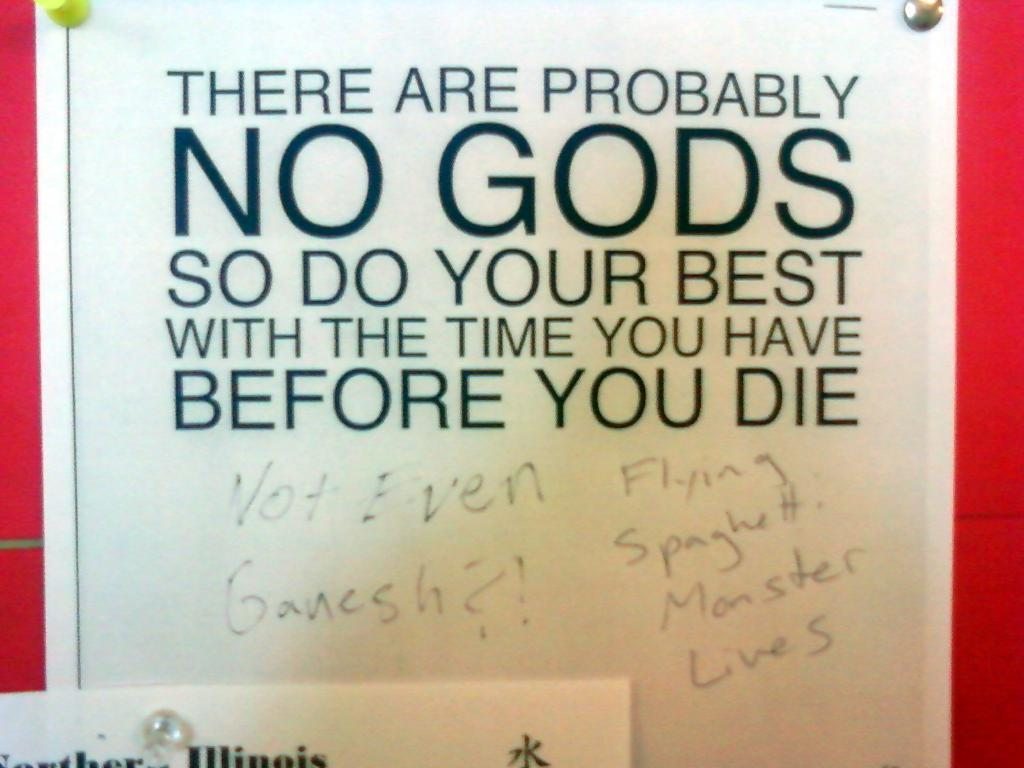<image>
Give a short and clear explanation of the subsequent image. Sign that says there are probably no gods so do your best with time before you die 